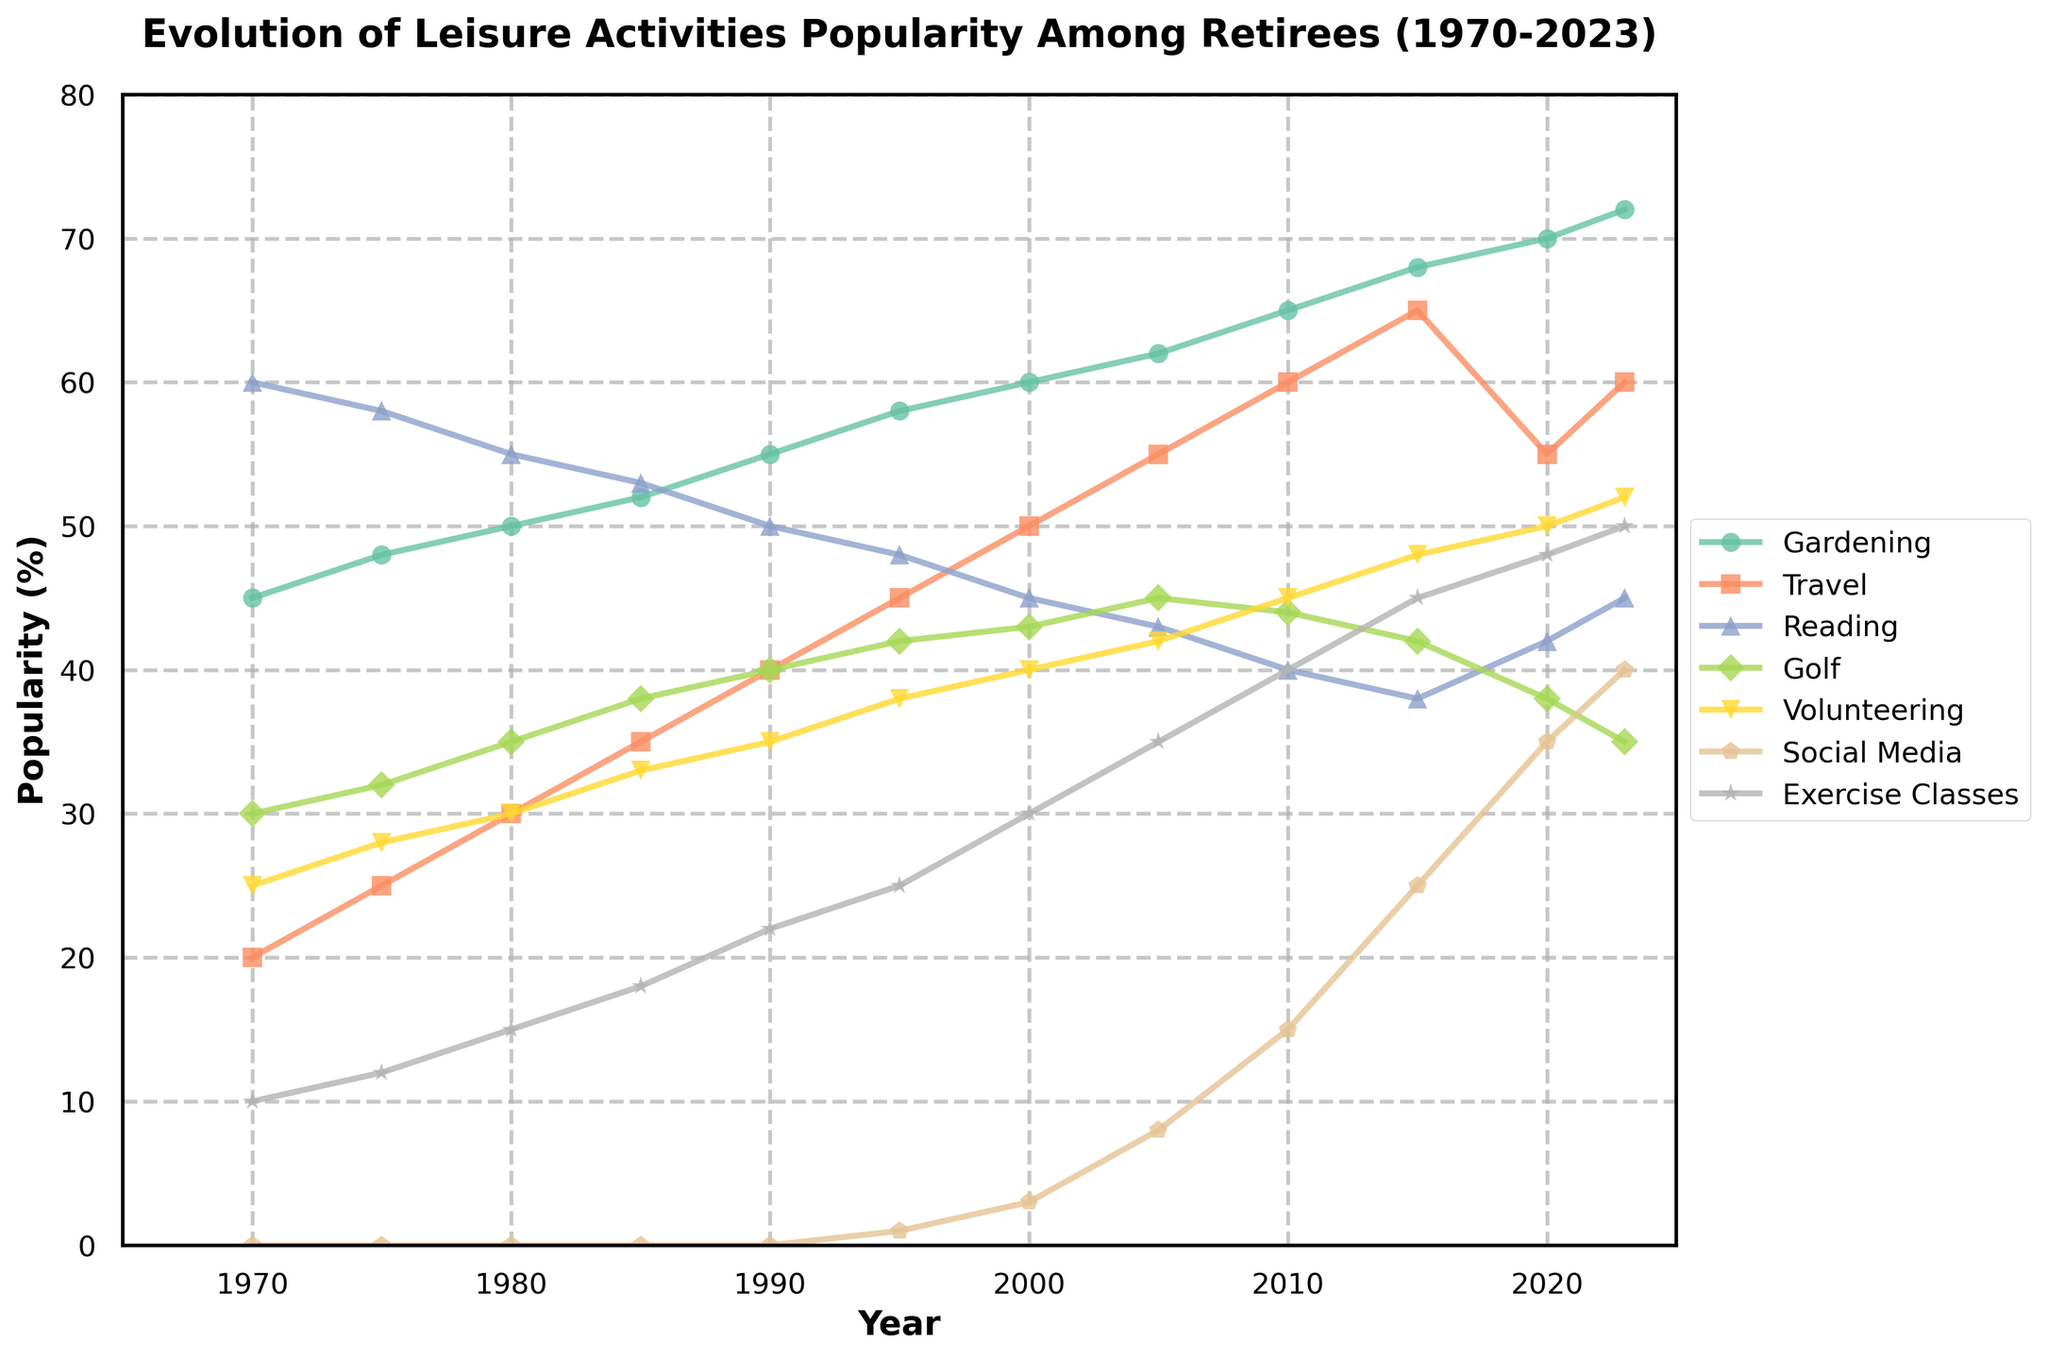What year did Social Media usage first appear among retirees? Social Media usage first appears in the year when its popularity shifts from 0. Checking the data, this change occurs between 1990 and 1995, marking 1995 as the first year Social Media is shown.
Answer: 1995 Which activity had the highest popularity in 1970? To determine this, compare the values for all activities in 1970. Gardening had 45%, Travel had 20%, Reading had 60%, Golf 30%, Volunteering 25%, Social Media 0%, and Exercise Classes 10%. Since Reading has the highest value, it is the most popular activity in 1970.
Answer: Reading How much did the popularity of Travel increase from 1980 to 1995? Check the popularity of Travel in 1980 and 1995. In 1980, it was 30%, and in 1995 it was 45%. Subtract the 1980 value from the 1995 value to find the increase: 45% - 30% = 15%.
Answer: 15% Which activity showed the most significant increase in popularity between 1970 and 2023? Calculate the differences in popularity for all activities between 1970 and 2023. Gardening increased from 45% to 72% (27% increase), Travel from 20% to 60% (40% increase), Reading from 60% to 45% (-15% decrease), Golf from 30% to 35% (5% increase), Volunteering from 25% to 52% (27% increase), Social Media from 0% to 40% (40% increase), and Exercise Classes from 10% to 50% (40% increase). Social Media, Travel, and Exercise Classes all increased by 40%, the highest.
Answer: Social Media, Travel, Exercise Classes Which year saw Gardening reach 65% popularity? Identify the year when Gardening hit the 65% mark specifically. From the data, this occurred in the year 2010.
Answer: 2010 Has any activity's popularity declined from 2000 to 2023? Compare the popularity of each activity in 2000 with that in 2023. Reading declined from 45% to 45% and Golf from 43% to 35%. Reading remained steady, while Golf clearly declined. Only Golf experienced a decline during this period.
Answer: Golf What is the average popularity of Exercise Classes between 1970 and 2023? Sum all values for Exercise Classes and divide by the number of years tracked. Exercises values are [10, 12, 15, 18, 22, 25, 30, 35, 40, 45, 48, 50]. Summing these: 10 + 12 + 15 + 18 + 22 + 25 + 30 + 35 + 40 + 45 + 48 + 50 = 350, then divide by 12 (years): 350 / 12 ≈ 29.17%.
Answer: 29.17% In which decade did Volunteering see the most rapid increase in popularity? Calculate the increase in popularity for each decade. From the data:
- 1970-1980: 30% - 25% = 5%
- 1980-1990: 35% - 30% = 5%
- 1990-2000: 40% - 35% = 5%
- 2000-2010: 45% - 40% = 5%
- 2010-2020: 50% - 45% = 5%
Since every decade had equal increases, identify this as the constant rate of 5%.
Answer: All decades equally Which year shows the most activities hitting peak popularity at the same time? By evaluating each activity, identify the peak popularity:
- Gardening: 72% in 2023
- Travel: 65% in 2015
- Reading: 60% in 1970
- Golf: 45% in 2005
- Volunteering: 52% in 2023
- Social Media: 40% in 2023
- Exercise Classes: 50% in 2023
The year 2023 sees Gardening, Volunteering, Social Media, and Exercise Classes all at their peak popularity.
Answer: 2023 